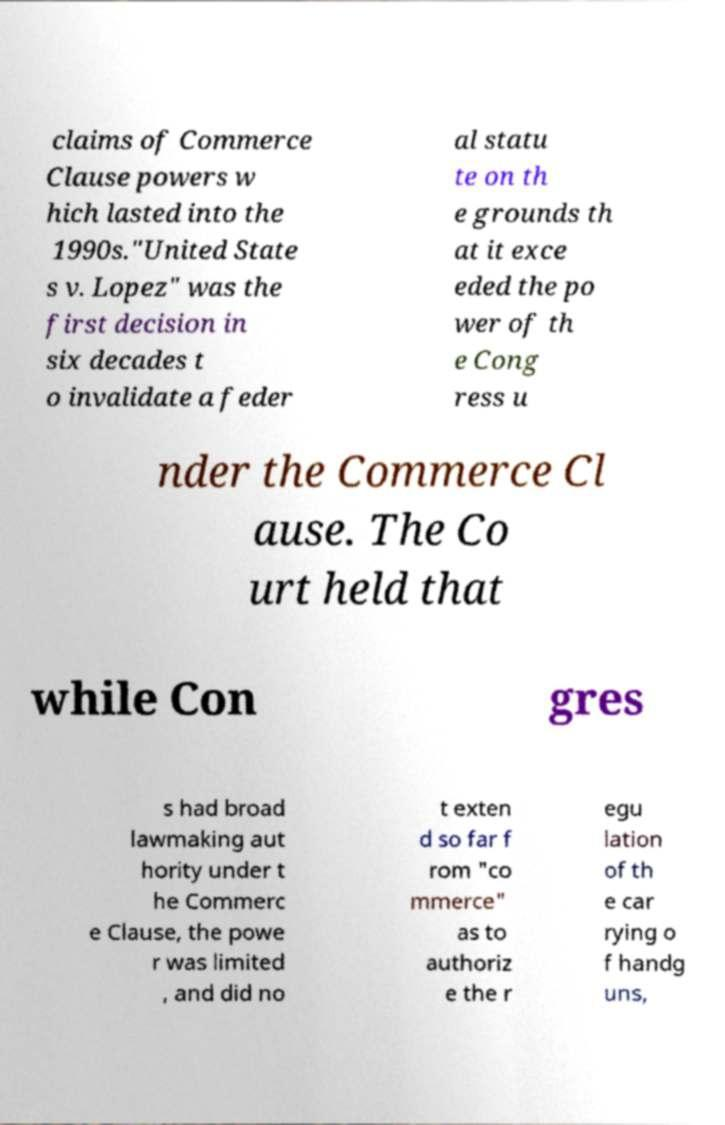Could you extract and type out the text from this image? claims of Commerce Clause powers w hich lasted into the 1990s."United State s v. Lopez" was the first decision in six decades t o invalidate a feder al statu te on th e grounds th at it exce eded the po wer of th e Cong ress u nder the Commerce Cl ause. The Co urt held that while Con gres s had broad lawmaking aut hority under t he Commerc e Clause, the powe r was limited , and did no t exten d so far f rom "co mmerce" as to authoriz e the r egu lation of th e car rying o f handg uns, 